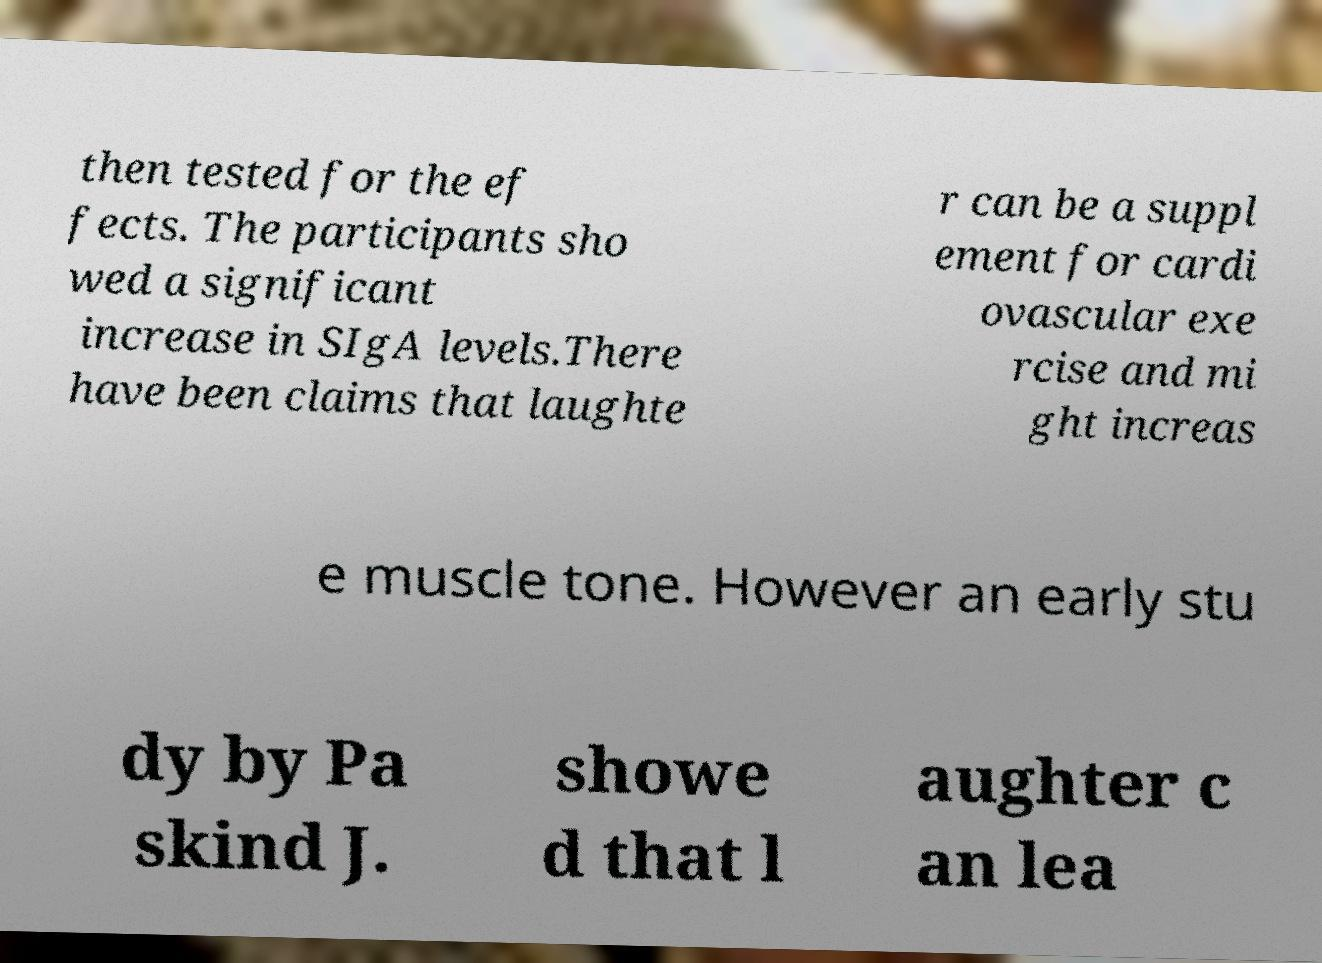Please identify and transcribe the text found in this image. then tested for the ef fects. The participants sho wed a significant increase in SIgA levels.There have been claims that laughte r can be a suppl ement for cardi ovascular exe rcise and mi ght increas e muscle tone. However an early stu dy by Pa skind J. showe d that l aughter c an lea 